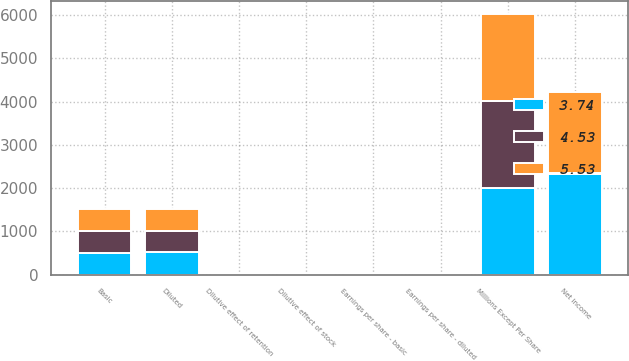Convert chart. <chart><loc_0><loc_0><loc_500><loc_500><stacked_bar_chart><ecel><fcel>Millions Except Per Share<fcel>Net income<fcel>Basic<fcel>Dilutive effect of stock<fcel>Dilutive effect of retention<fcel>Diluted<fcel>Earnings per share - basic<fcel>Earnings per share - diluted<nl><fcel>4.53<fcel>2010<fcel>5.58<fcel>498.2<fcel>3.3<fcel>1.4<fcel>502.9<fcel>5.58<fcel>5.53<nl><fcel>5.53<fcel>2009<fcel>1890<fcel>503<fcel>1.5<fcel>1.3<fcel>505.8<fcel>3.76<fcel>3.74<nl><fcel>3.74<fcel>2008<fcel>2335<fcel>510.6<fcel>3.4<fcel>1<fcel>515<fcel>4.57<fcel>4.53<nl></chart> 